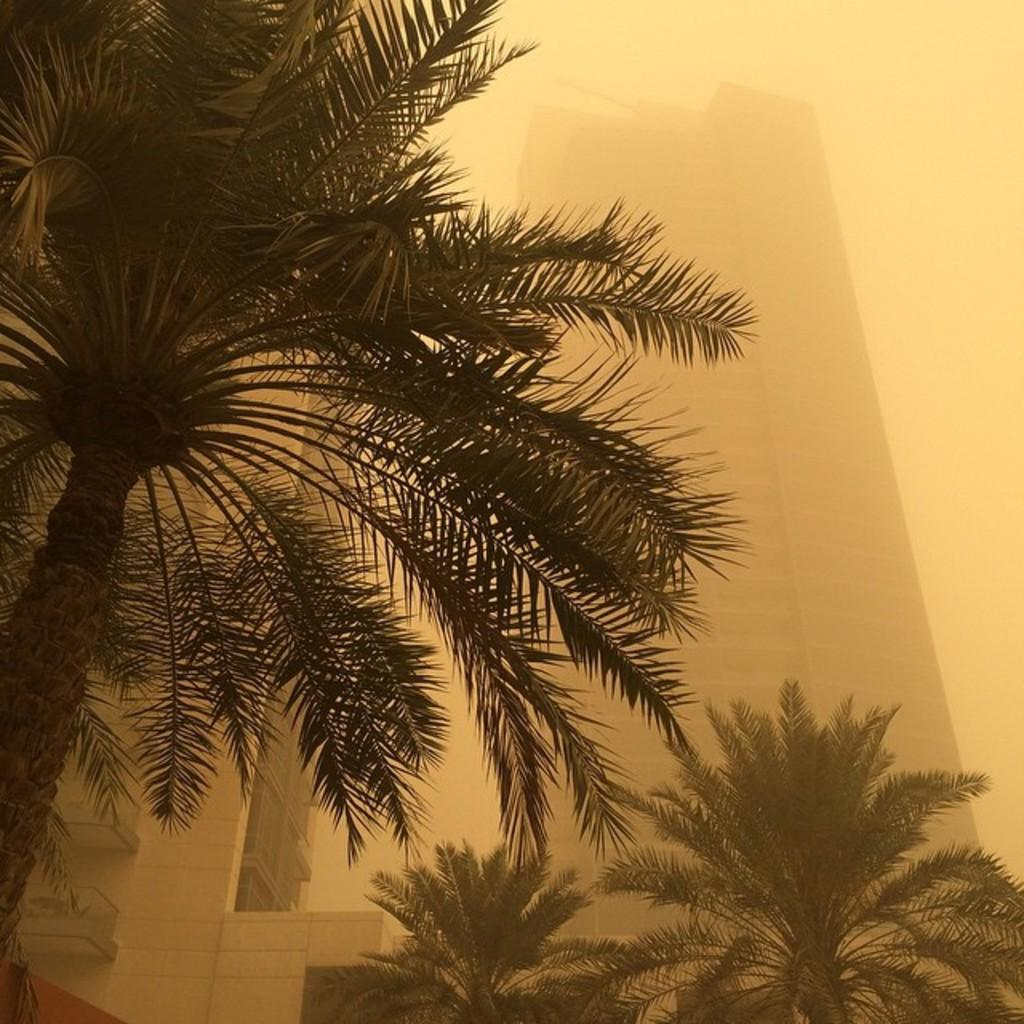What type of natural elements can be seen in the image? There are trees in the image. What type of man-made structures are present in the image? There are buildings in the image. What atmospheric condition is visible in the image? There is fog in the image. What is visible at the top of the image? The sky is visible at the top of the image. Where is the basketball court located in the image? There is no basketball court present in the image. What type of wheel can be seen on the buildings in the image? There are no wheels visible on the buildings in the image. 